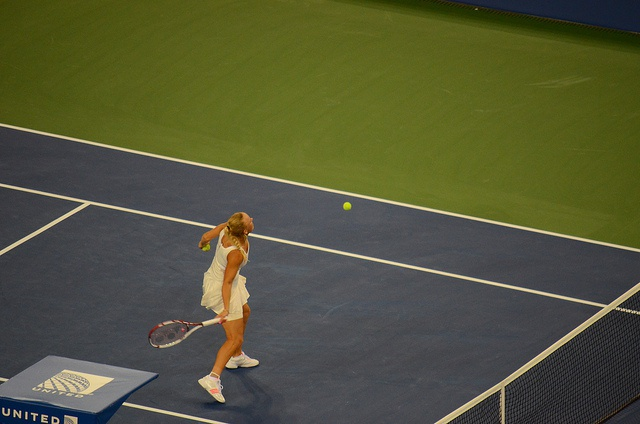Describe the objects in this image and their specific colors. I can see people in darkgreen, red, and tan tones, tennis racket in darkgreen, gray, maroon, and tan tones, sports ball in darkgreen, yellow, olive, and khaki tones, and sports ball in darkgreen, olive, and gray tones in this image. 